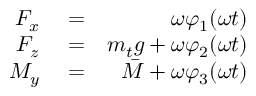Convert formula to latex. <formula><loc_0><loc_0><loc_500><loc_500>\begin{array} { r l r } { F _ { x } } & = } & { \omega \varphi _ { 1 } ( \omega t ) } \\ { F _ { z } } & = } & { m _ { t } g + \omega \varphi _ { 2 } ( \omega t ) } \\ { M _ { y } } & = } & { \bar { M } + \omega \varphi _ { 3 } ( \omega t ) } \end{array}</formula> 